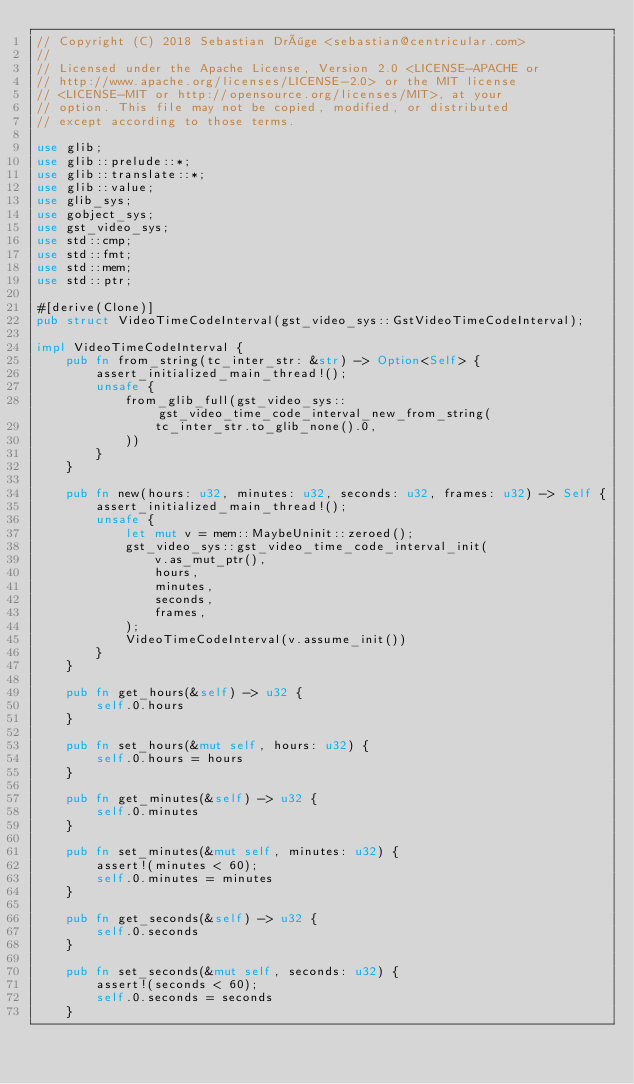<code> <loc_0><loc_0><loc_500><loc_500><_Rust_>// Copyright (C) 2018 Sebastian Dröge <sebastian@centricular.com>
//
// Licensed under the Apache License, Version 2.0 <LICENSE-APACHE or
// http://www.apache.org/licenses/LICENSE-2.0> or the MIT license
// <LICENSE-MIT or http://opensource.org/licenses/MIT>, at your
// option. This file may not be copied, modified, or distributed
// except according to those terms.

use glib;
use glib::prelude::*;
use glib::translate::*;
use glib::value;
use glib_sys;
use gobject_sys;
use gst_video_sys;
use std::cmp;
use std::fmt;
use std::mem;
use std::ptr;

#[derive(Clone)]
pub struct VideoTimeCodeInterval(gst_video_sys::GstVideoTimeCodeInterval);

impl VideoTimeCodeInterval {
    pub fn from_string(tc_inter_str: &str) -> Option<Self> {
        assert_initialized_main_thread!();
        unsafe {
            from_glib_full(gst_video_sys::gst_video_time_code_interval_new_from_string(
                tc_inter_str.to_glib_none().0,
            ))
        }
    }

    pub fn new(hours: u32, minutes: u32, seconds: u32, frames: u32) -> Self {
        assert_initialized_main_thread!();
        unsafe {
            let mut v = mem::MaybeUninit::zeroed();
            gst_video_sys::gst_video_time_code_interval_init(
                v.as_mut_ptr(),
                hours,
                minutes,
                seconds,
                frames,
            );
            VideoTimeCodeInterval(v.assume_init())
        }
    }

    pub fn get_hours(&self) -> u32 {
        self.0.hours
    }

    pub fn set_hours(&mut self, hours: u32) {
        self.0.hours = hours
    }

    pub fn get_minutes(&self) -> u32 {
        self.0.minutes
    }

    pub fn set_minutes(&mut self, minutes: u32) {
        assert!(minutes < 60);
        self.0.minutes = minutes
    }

    pub fn get_seconds(&self) -> u32 {
        self.0.seconds
    }

    pub fn set_seconds(&mut self, seconds: u32) {
        assert!(seconds < 60);
        self.0.seconds = seconds
    }
</code> 